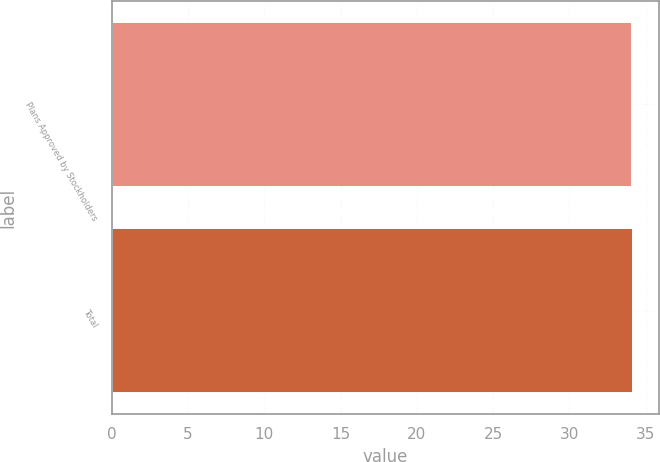Convert chart to OTSL. <chart><loc_0><loc_0><loc_500><loc_500><bar_chart><fcel>Plans Approved by Stockholders<fcel>Total<nl><fcel>34.12<fcel>34.16<nl></chart> 